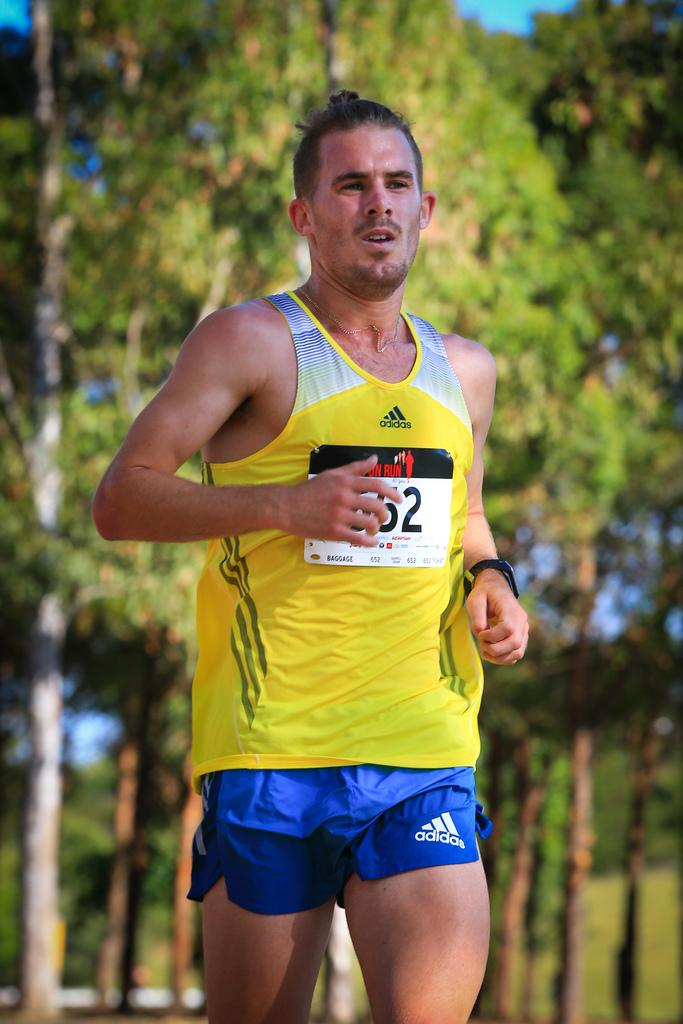<image>
Summarize the visual content of the image. the number 52 that is on a jersey 